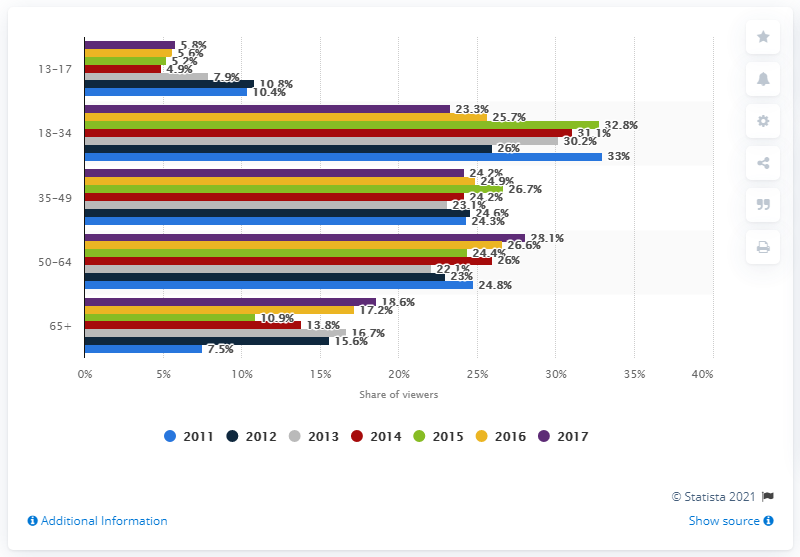Draw attention to some important aspects in this diagram. In 2011, it was reported that 33% of adults in the United States watched Major League Soccer on television. According to data from 2017, a significant portion of adults who watched Major League Soccer on television were between the ages of 18 and 34, with 23.3% falling into that age range. 